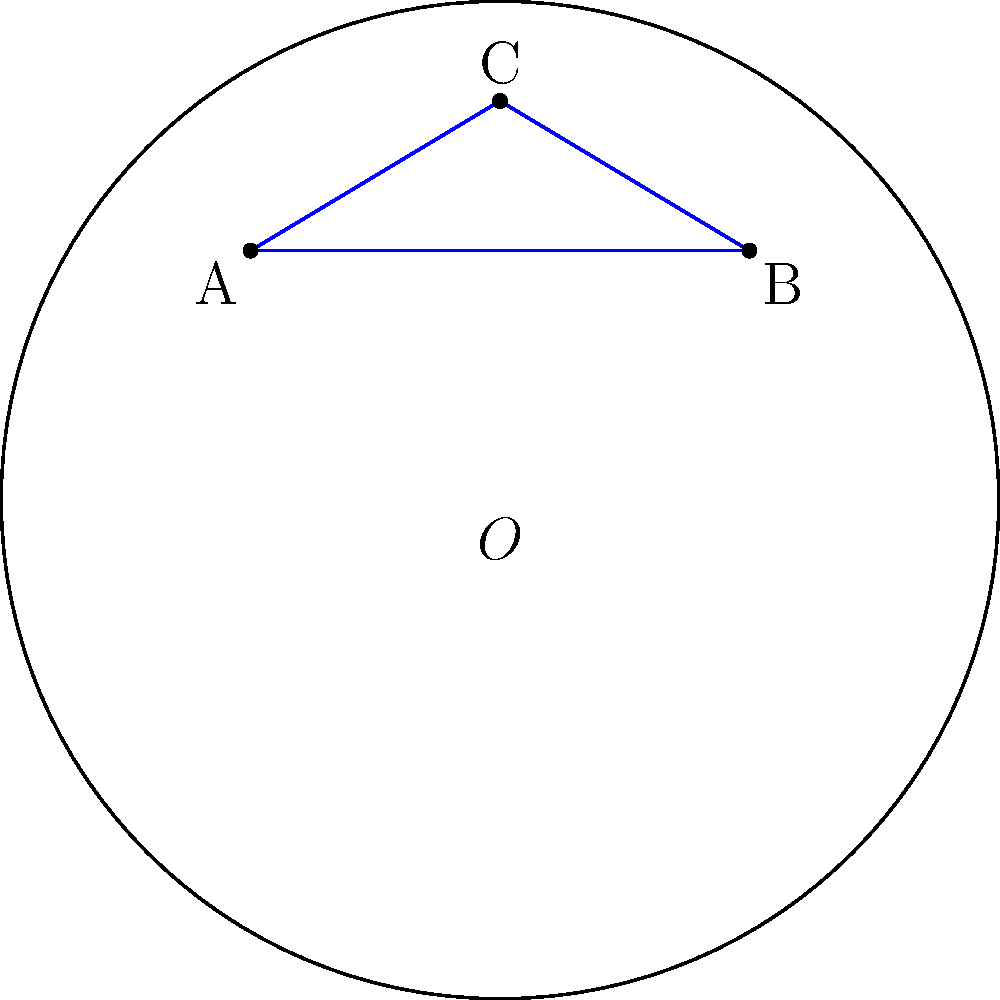In the Poincaré disk model of hyperbolic geometry shown above, triangle ABC is drawn. If the sum of the interior angles of this triangle is $\frac{5\pi}{6}$, what is the area of the triangle in terms of $\pi$? To solve this problem, we'll use the following steps:

1) In hyperbolic geometry, the area of a triangle is related to its angle defect. The formula is:

   Area = $(\pi - (\alpha + \beta + \gamma))R^2$

   Where $\alpha$, $\beta$, and $\gamma$ are the interior angles of the triangle, and $R$ is the radius of curvature.

2) In the Poincaré disk model, the radius of curvature is 1.

3) We're given that the sum of the interior angles is $\frac{5\pi}{6}$. Let's call this sum $S$:

   $S = \frac{5\pi}{6}$

4) The angle defect is the difference between $\pi$ and $S$:

   Angle defect = $\pi - S = \pi - \frac{5\pi}{6} = \frac{\pi}{6}$

5) Now we can use the area formula:

   Area = $(\pi - (\alpha + \beta + \gamma))R^2 = (\pi - \frac{5\pi}{6}) \cdot 1^2 = \frac{\pi}{6}$

Therefore, the area of the triangle is $\frac{\pi}{6}$.
Answer: $\frac{\pi}{6}$ 